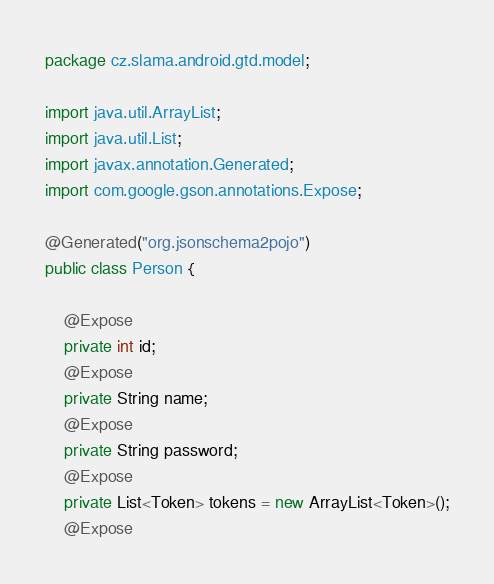Convert code to text. <code><loc_0><loc_0><loc_500><loc_500><_Java_>
package cz.slama.android.gtd.model;

import java.util.ArrayList;
import java.util.List;
import javax.annotation.Generated;
import com.google.gson.annotations.Expose;

@Generated("org.jsonschema2pojo")
public class Person {

    @Expose
    private int id;
    @Expose
    private String name;
    @Expose
    private String password;
    @Expose
    private List<Token> tokens = new ArrayList<Token>();
    @Expose</code> 